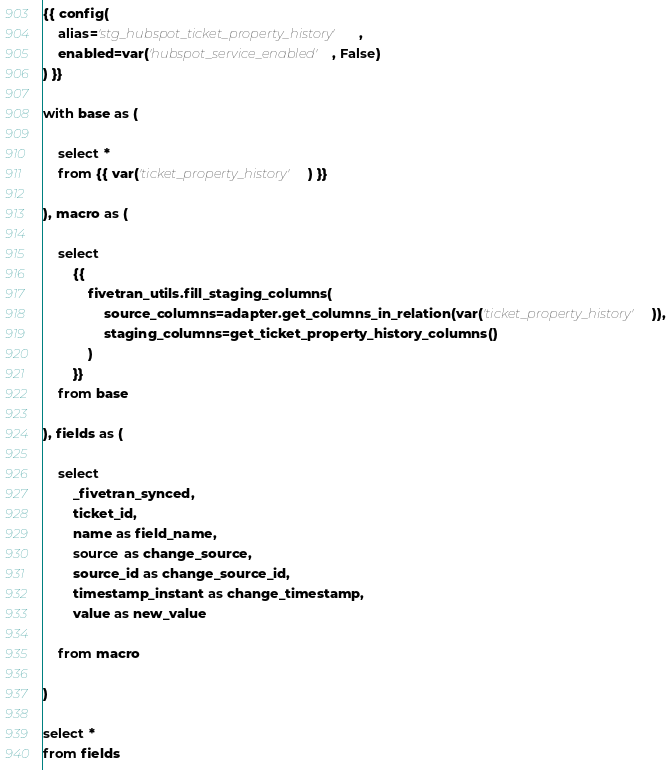Convert code to text. <code><loc_0><loc_0><loc_500><loc_500><_SQL_>{{ config(
    alias='stg_hubspot_ticket_property_history',
    enabled=var('hubspot_service_enabled', False)
) }}

with base as (

    select *
    from {{ var('ticket_property_history') }}

), macro as (

    select
        {{
            fivetran_utils.fill_staging_columns(
                source_columns=adapter.get_columns_in_relation(var('ticket_property_history')),
                staging_columns=get_ticket_property_history_columns()
            )
        }}
    from base

), fields as (

    select
        _fivetran_synced,
        ticket_id,
        name as field_name,
        source as change_source,
        source_id as change_source_id,
        timestamp_instant as change_timestamp,
        value as new_value

    from macro

)

select *
from fields
</code> 